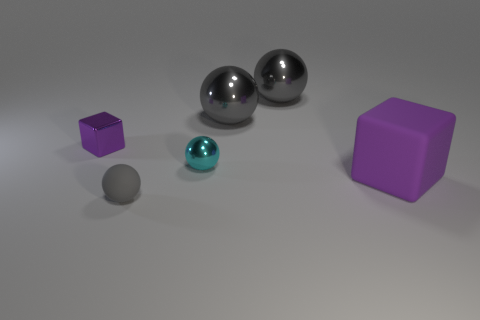What size is the purple cube that is behind the big matte block?
Your answer should be compact. Small. There is a purple cube to the right of the purple cube behind the big purple block; what size is it?
Make the answer very short. Large. Is the number of cyan things greater than the number of large yellow metal objects?
Keep it short and to the point. Yes. Are there more tiny gray balls behind the big purple rubber cube than matte blocks to the left of the small gray rubber thing?
Provide a short and direct response. No. There is a thing that is left of the tiny cyan sphere and in front of the small cyan object; how big is it?
Ensure brevity in your answer.  Small. How many shiny things are the same size as the purple matte object?
Provide a succinct answer. 2. There is another block that is the same color as the tiny block; what is its material?
Your response must be concise. Rubber. There is a metallic thing that is left of the tiny matte object; does it have the same shape as the small cyan object?
Provide a short and direct response. No. Is the number of small rubber balls left of the gray matte object less than the number of gray metallic spheres?
Your answer should be compact. Yes. Are there any big shiny cubes of the same color as the big rubber block?
Make the answer very short. No. 